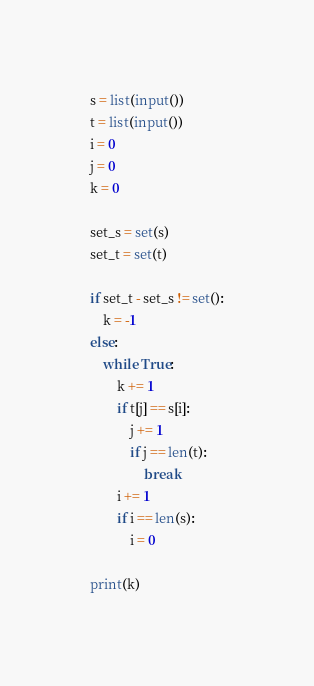Convert code to text. <code><loc_0><loc_0><loc_500><loc_500><_Python_>s = list(input())
t = list(input())
i = 0
j = 0
k = 0

set_s = set(s)
set_t = set(t)

if set_t - set_s != set():
    k = -1
else:
    while True:
        k += 1
        if t[j] == s[i]:
            j += 1
            if j == len(t):
                break
        i += 1
        if i == len(s):
            i = 0

print(k)
</code> 